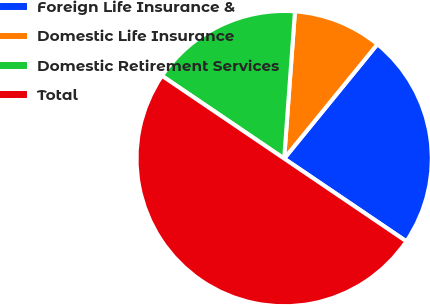Convert chart to OTSL. <chart><loc_0><loc_0><loc_500><loc_500><pie_chart><fcel>Foreign Life Insurance &<fcel>Domestic Life Insurance<fcel>Domestic Retirement Services<fcel>Total<nl><fcel>23.59%<fcel>9.72%<fcel>16.69%<fcel>50.0%<nl></chart> 